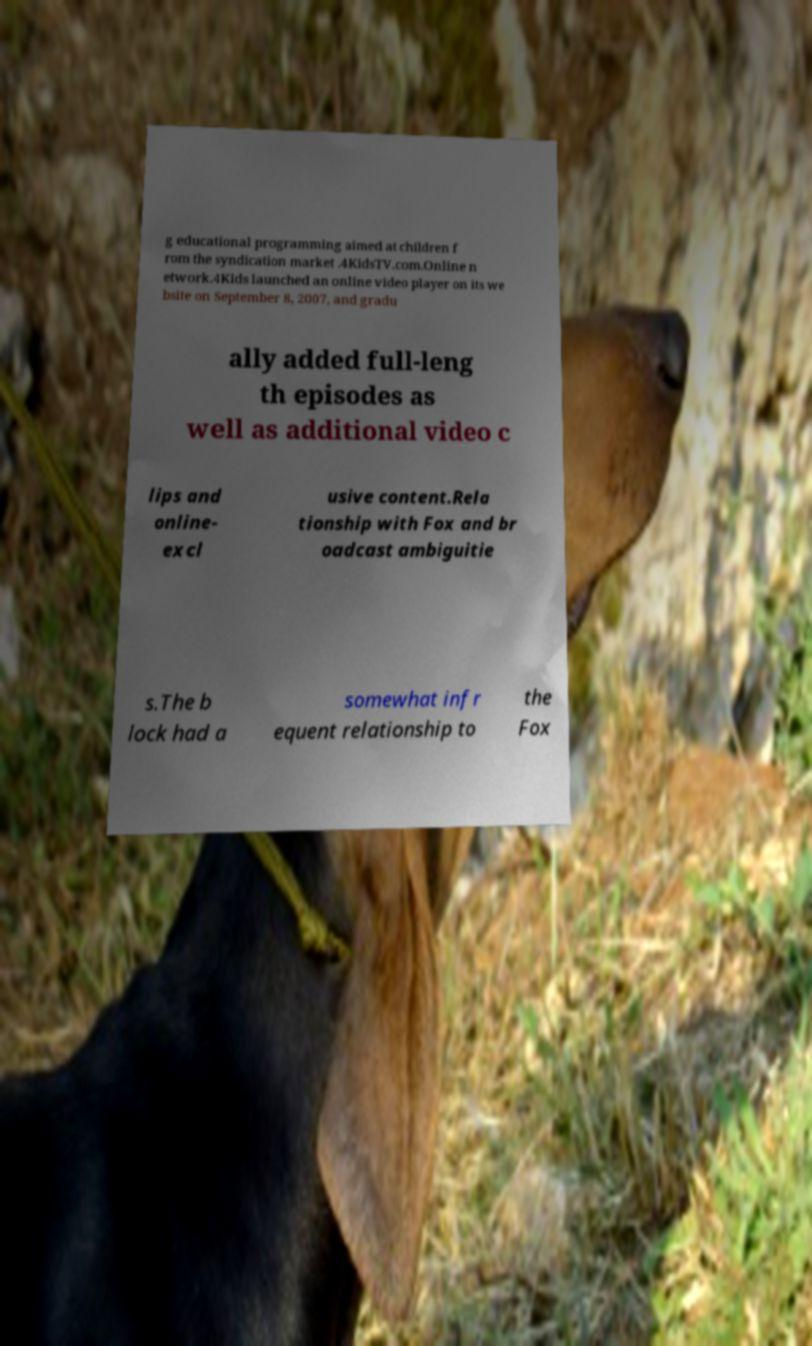Can you accurately transcribe the text from the provided image for me? g educational programming aimed at children f rom the syndication market .4KidsTV.com.Online n etwork.4Kids launched an online video player on its we bsite on September 8, 2007, and gradu ally added full-leng th episodes as well as additional video c lips and online- excl usive content.Rela tionship with Fox and br oadcast ambiguitie s.The b lock had a somewhat infr equent relationship to the Fox 